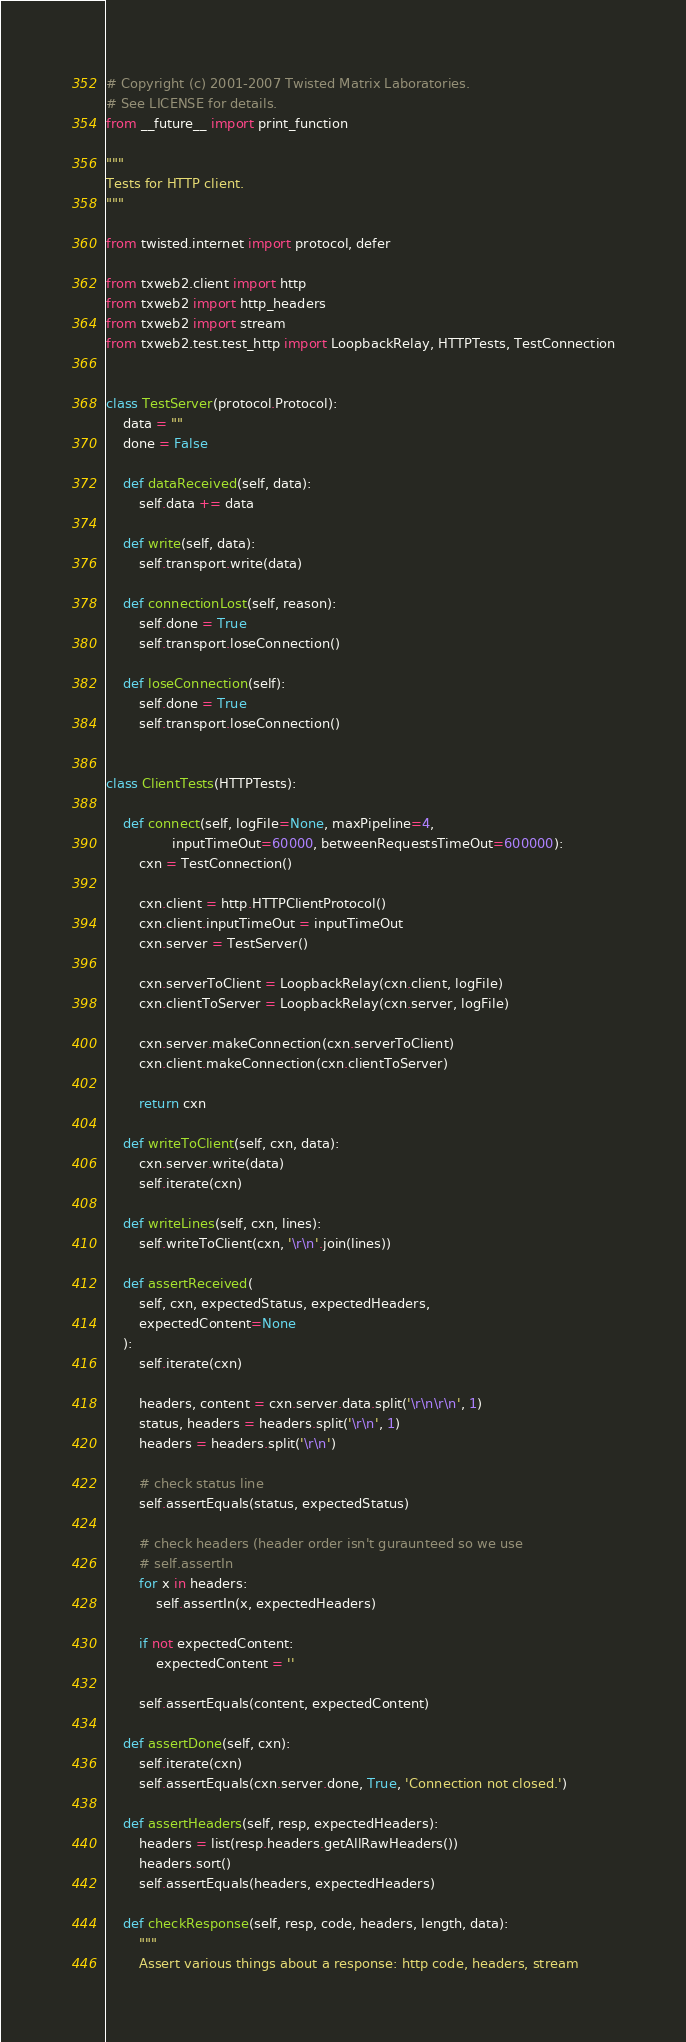Convert code to text. <code><loc_0><loc_0><loc_500><loc_500><_Python_># Copyright (c) 2001-2007 Twisted Matrix Laboratories.
# See LICENSE for details.
from __future__ import print_function

"""
Tests for HTTP client.
"""

from twisted.internet import protocol, defer

from txweb2.client import http
from txweb2 import http_headers
from txweb2 import stream
from txweb2.test.test_http import LoopbackRelay, HTTPTests, TestConnection


class TestServer(protocol.Protocol):
    data = ""
    done = False

    def dataReceived(self, data):
        self.data += data

    def write(self, data):
        self.transport.write(data)

    def connectionLost(self, reason):
        self.done = True
        self.transport.loseConnection()

    def loseConnection(self):
        self.done = True
        self.transport.loseConnection()


class ClientTests(HTTPTests):

    def connect(self, logFile=None, maxPipeline=4,
                inputTimeOut=60000, betweenRequestsTimeOut=600000):
        cxn = TestConnection()

        cxn.client = http.HTTPClientProtocol()
        cxn.client.inputTimeOut = inputTimeOut
        cxn.server = TestServer()

        cxn.serverToClient = LoopbackRelay(cxn.client, logFile)
        cxn.clientToServer = LoopbackRelay(cxn.server, logFile)

        cxn.server.makeConnection(cxn.serverToClient)
        cxn.client.makeConnection(cxn.clientToServer)

        return cxn

    def writeToClient(self, cxn, data):
        cxn.server.write(data)
        self.iterate(cxn)

    def writeLines(self, cxn, lines):
        self.writeToClient(cxn, '\r\n'.join(lines))

    def assertReceived(
        self, cxn, expectedStatus, expectedHeaders,
        expectedContent=None
    ):
        self.iterate(cxn)

        headers, content = cxn.server.data.split('\r\n\r\n', 1)
        status, headers = headers.split('\r\n', 1)
        headers = headers.split('\r\n')

        # check status line
        self.assertEquals(status, expectedStatus)

        # check headers (header order isn't guraunteed so we use
        # self.assertIn
        for x in headers:
            self.assertIn(x, expectedHeaders)

        if not expectedContent:
            expectedContent = ''

        self.assertEquals(content, expectedContent)

    def assertDone(self, cxn):
        self.iterate(cxn)
        self.assertEquals(cxn.server.done, True, 'Connection not closed.')

    def assertHeaders(self, resp, expectedHeaders):
        headers = list(resp.headers.getAllRawHeaders())
        headers.sort()
        self.assertEquals(headers, expectedHeaders)

    def checkResponse(self, resp, code, headers, length, data):
        """
        Assert various things about a response: http code, headers, stream</code> 